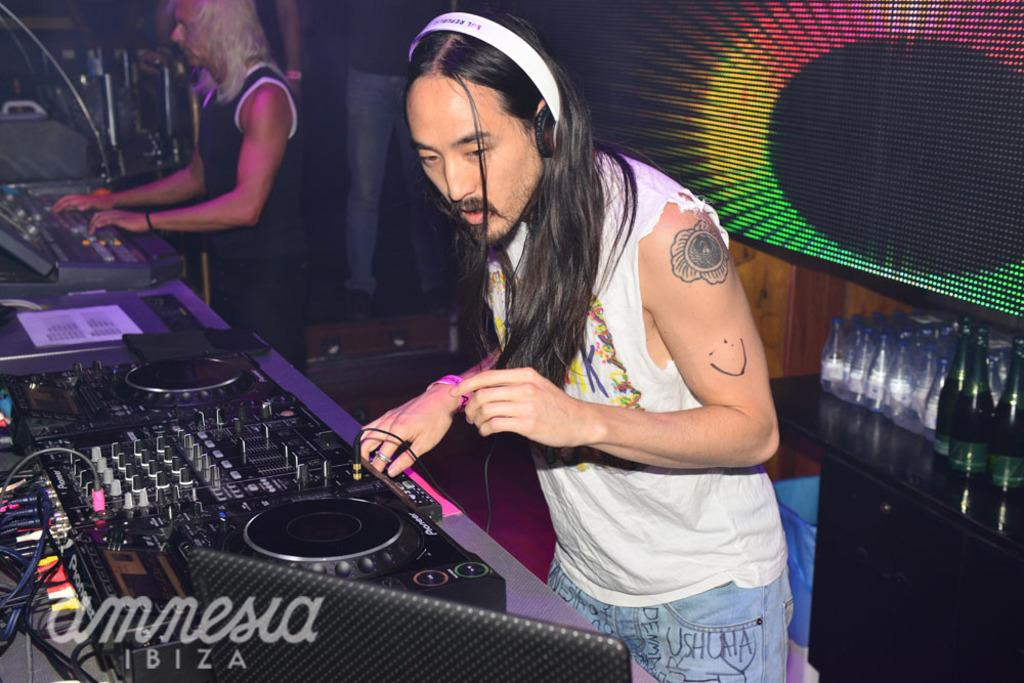What are the persons in the image doing? The persons in the image are playing musical instruments. Can you describe the table in the image? There is a wooden table in the image with bottles on it. Is there a knife being used to cut the musical instruments in the image? There is no knife or cutting of musical instruments depicted in the image. 